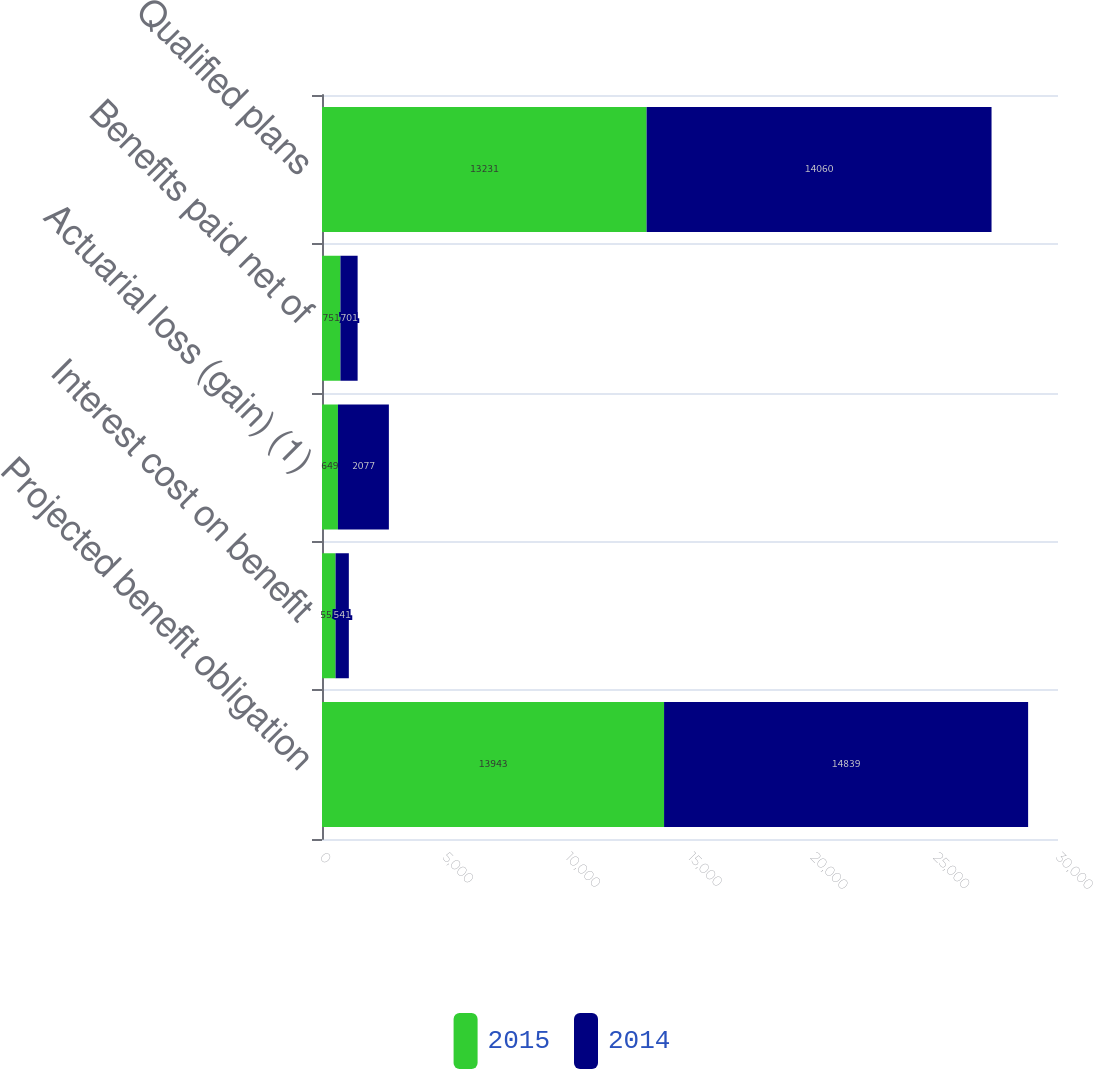Convert chart. <chart><loc_0><loc_0><loc_500><loc_500><stacked_bar_chart><ecel><fcel>Projected benefit obligation<fcel>Interest cost on benefit<fcel>Actuarial loss (gain) (1)<fcel>Benefits paid net of<fcel>Qualified plans<nl><fcel>2015<fcel>13943<fcel>553<fcel>649<fcel>751<fcel>13231<nl><fcel>2014<fcel>14839<fcel>541<fcel>2077<fcel>701<fcel>14060<nl></chart> 